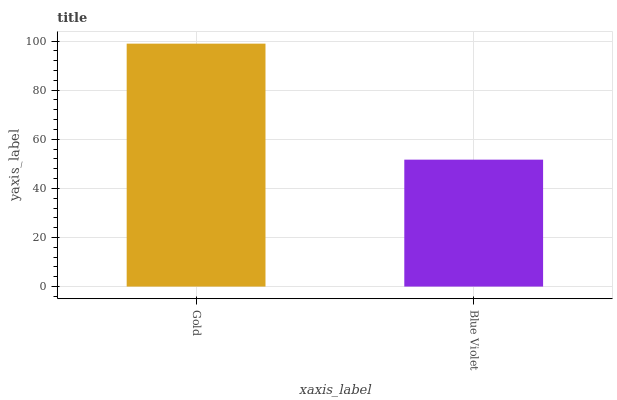Is Blue Violet the minimum?
Answer yes or no. Yes. Is Gold the maximum?
Answer yes or no. Yes. Is Blue Violet the maximum?
Answer yes or no. No. Is Gold greater than Blue Violet?
Answer yes or no. Yes. Is Blue Violet less than Gold?
Answer yes or no. Yes. Is Blue Violet greater than Gold?
Answer yes or no. No. Is Gold less than Blue Violet?
Answer yes or no. No. Is Gold the high median?
Answer yes or no. Yes. Is Blue Violet the low median?
Answer yes or no. Yes. Is Blue Violet the high median?
Answer yes or no. No. Is Gold the low median?
Answer yes or no. No. 